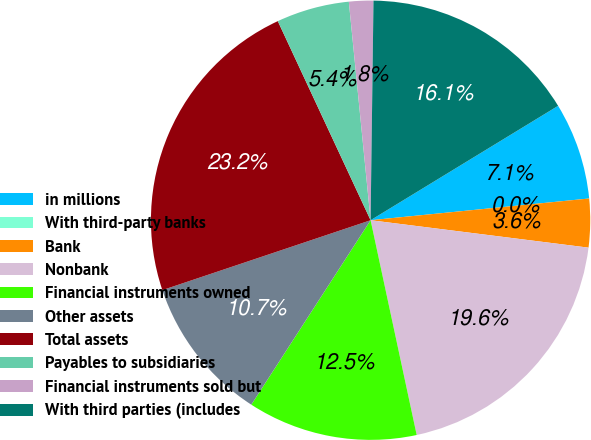Convert chart. <chart><loc_0><loc_0><loc_500><loc_500><pie_chart><fcel>in millions<fcel>With third-party banks<fcel>Bank<fcel>Nonbank<fcel>Financial instruments owned<fcel>Other assets<fcel>Total assets<fcel>Payables to subsidiaries<fcel>Financial instruments sold but<fcel>With third parties (includes<nl><fcel>7.14%<fcel>0.0%<fcel>3.57%<fcel>19.64%<fcel>12.5%<fcel>10.71%<fcel>23.21%<fcel>5.36%<fcel>1.79%<fcel>16.07%<nl></chart> 